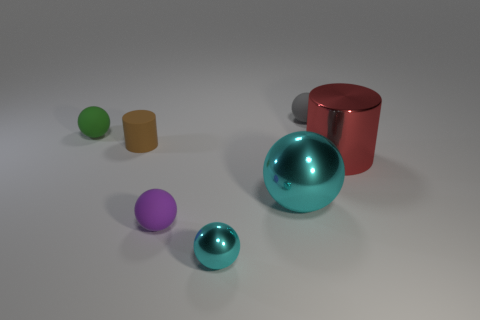Subtract all green spheres. How many spheres are left? 4 Subtract all green spheres. How many spheres are left? 4 Subtract all yellow spheres. Subtract all brown cubes. How many spheres are left? 5 Add 2 small purple matte things. How many objects exist? 9 Subtract all spheres. How many objects are left? 2 Add 3 large green things. How many large green things exist? 3 Subtract 1 gray spheres. How many objects are left? 6 Subtract all tiny gray rubber things. Subtract all brown matte objects. How many objects are left? 5 Add 1 small brown rubber cylinders. How many small brown rubber cylinders are left? 2 